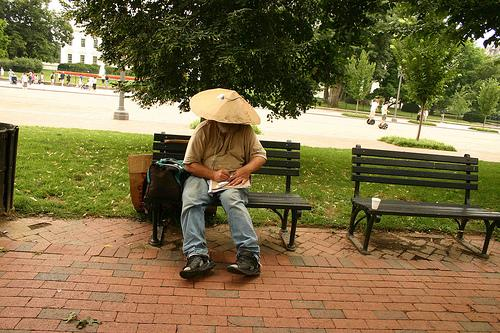Identify the object on the bench besides the man and describe the bench's legs. There is a coffee cup on the bench and the bench has legs made of a sturdy material. Name the type of container near the pathway and mention its exact location. A trash can is placed right next to the pathway, ensuring a clean environment. Mention what the person in the image is doing and what they are wearing on their head. A man is sitting on a bench, writing, and wearing a conical hat on his head. What type of headwear is the man in the image wearing, and what activity is he engaged in? The man is wearing a conical hat and is busy writing. State the main action of the person in the photo and describe the hat they are wearing. In the photo, a man is writing while sporting a hat with a conical shape. What kind of gathering is happening in the image? A group of people is gathering together, possibly for a social event or discussion. Describe the two people doing an activity using a specific mode of transportation. Two individuals are riding Segways, enjoying a modern and electric way to get around. State the type of ground the pathway is made from and what is adjacent to it. The pathway is made from red bricks, and there is a trash can next to it. Mention what type of footwear the man is wearing. The man is wearing black sandals. Describe the pathway and the type of ground covering. The pathway is paved with red bricks, and there is grass on the ground around it. 